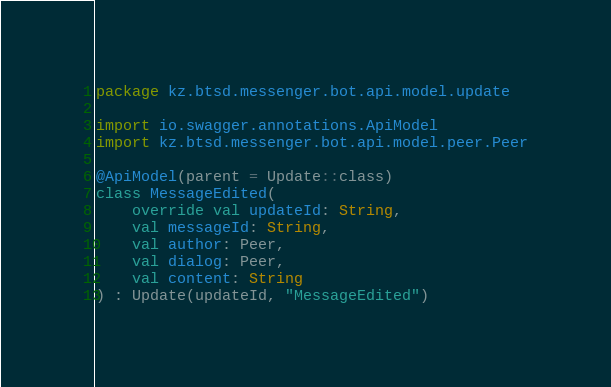<code> <loc_0><loc_0><loc_500><loc_500><_Kotlin_>package kz.btsd.messenger.bot.api.model.update

import io.swagger.annotations.ApiModel
import kz.btsd.messenger.bot.api.model.peer.Peer

@ApiModel(parent = Update::class)
class MessageEdited(
    override val updateId: String,
    val messageId: String,
    val author: Peer,
    val dialog: Peer,
    val content: String
) : Update(updateId, "MessageEdited")
</code> 